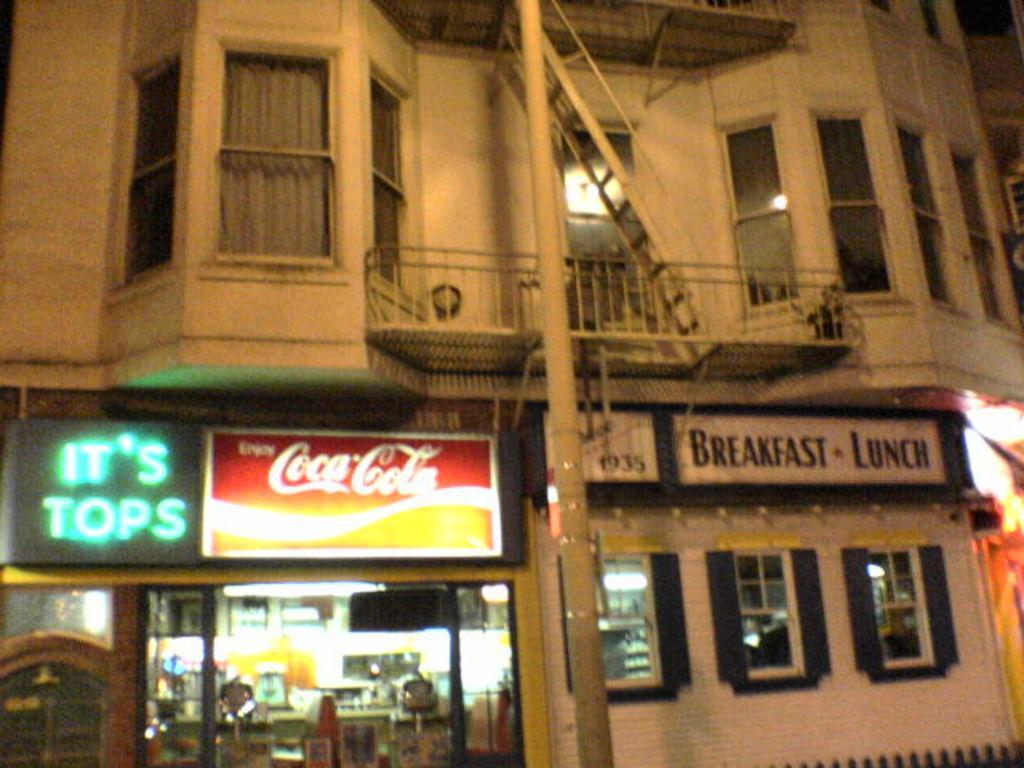In one or two sentences, can you explain what this image depicts? This image is taken during night time. In this image we can see the outside view of a building. We can also see the boards with text. Pole is also visible. 